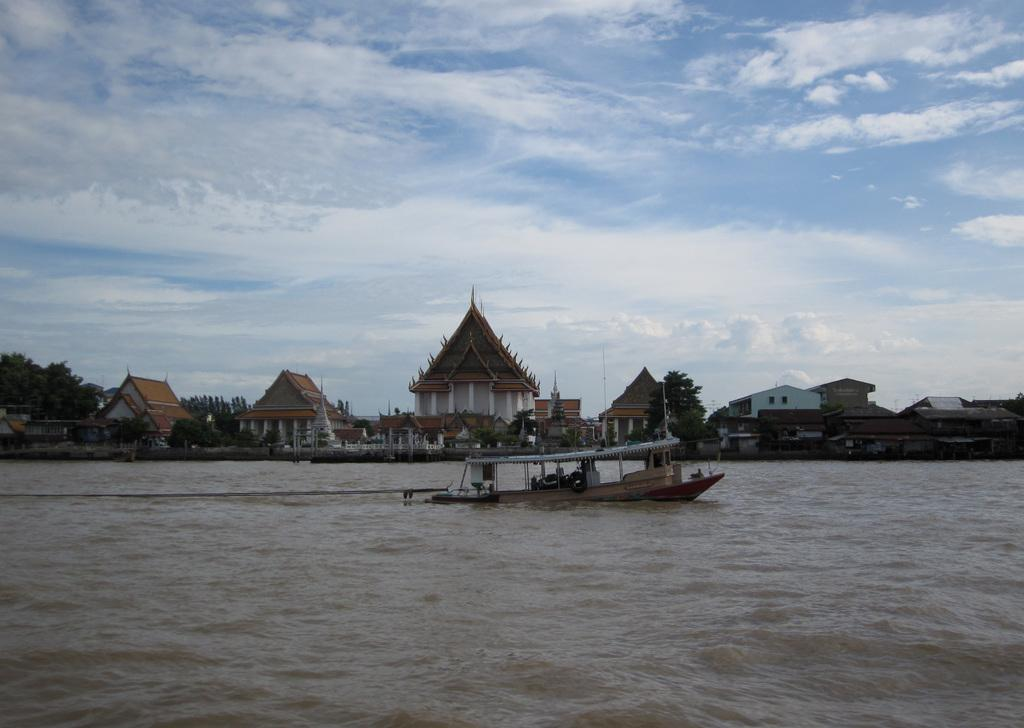What is the main subject of the image? The main subject of the image is a boat. Where is the boat located? The boat is on the water. What can be seen in the background of the image? There are buildings and trees in the background of the image. What is visible at the top of the image? The sky is visible at the top of the image. What can be observed in the sky? Clouds are present in the sky. What type of pump is used to propel the boat in the image? There is no pump present in the image; the boat is likely being propelled by a motor or sails. Can you hear the bells ringing in the image? There are no bells present in the image, so it is not possible to hear them ringing. 